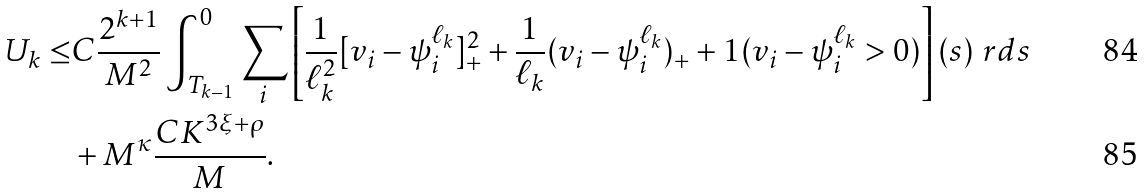Convert formula to latex. <formula><loc_0><loc_0><loc_500><loc_500>U _ { k } \leq & C \frac { 2 ^ { k + 1 } } { M ^ { 2 } } \int _ { T _ { k - 1 } } ^ { 0 } \sum _ { i } \left [ \frac { 1 } { \ell _ { k } ^ { 2 } } [ v _ { i } - \psi ^ { \ell _ { k } } _ { i } ] _ { + } ^ { 2 } + \frac { 1 } { \ell _ { k } } ( v _ { i } - \psi ^ { \ell _ { k } } _ { i } ) _ { + } + { 1 } ( v _ { i } - \psi ^ { \ell _ { k } } _ { i } > 0 ) \right ] ( s ) \ r d s \\ & + M ^ { \kappa } \frac { C K ^ { 3 \xi + \rho } } M .</formula> 